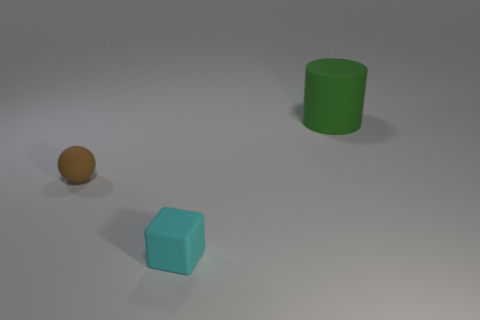There is a tiny object that is to the right of the object on the left side of the matte cube; what is its material?
Ensure brevity in your answer.  Rubber. What number of cubes have the same color as the rubber ball?
Provide a succinct answer. 0. Is the number of brown rubber things behind the big green matte cylinder less than the number of big cubes?
Your response must be concise. No. The small rubber thing that is in front of the tiny thing behind the tiny cyan object is what color?
Ensure brevity in your answer.  Cyan. There is a object behind the tiny matte thing on the left side of the rubber object that is in front of the small brown object; what is its size?
Ensure brevity in your answer.  Large. Is the number of tiny cyan matte cubes behind the large matte cylinder less than the number of small brown matte things that are behind the brown matte ball?
Keep it short and to the point. No. What number of balls are made of the same material as the tiny cube?
Offer a very short reply. 1. There is a tiny rubber thing to the left of the small thing in front of the brown object; is there a brown thing that is to the left of it?
Give a very brief answer. No. There is a cyan thing that is made of the same material as the big green cylinder; what shape is it?
Provide a short and direct response. Cube. Are there more tiny cyan matte blocks than tiny yellow cylinders?
Offer a terse response. Yes. 